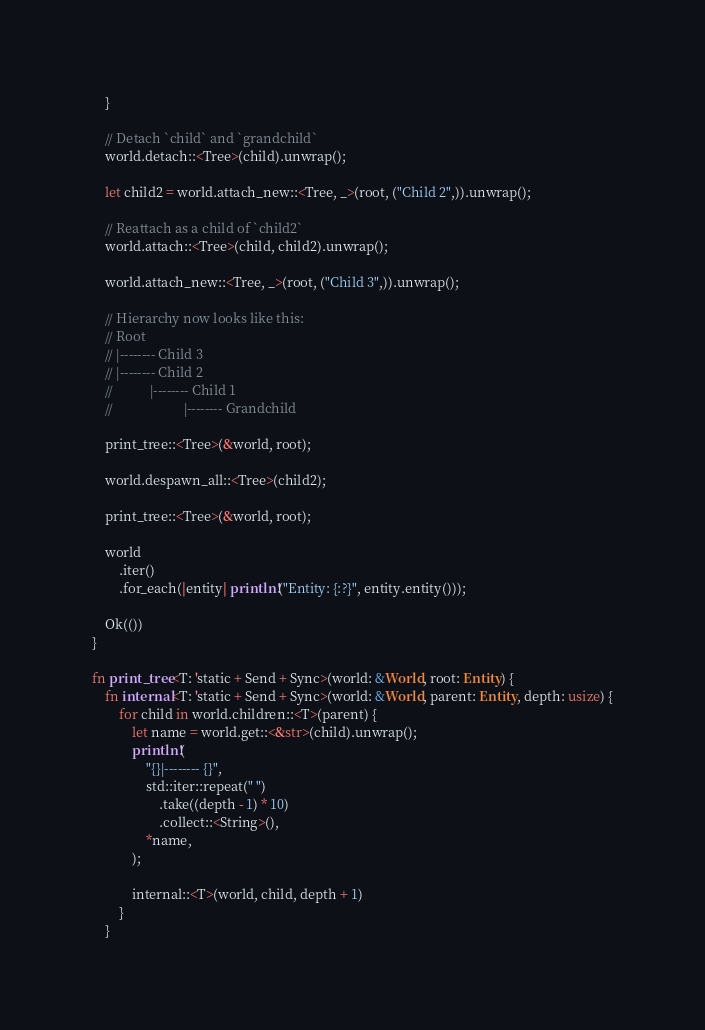Convert code to text. <code><loc_0><loc_0><loc_500><loc_500><_Rust_>    }

    // Detach `child` and `grandchild`
    world.detach::<Tree>(child).unwrap();

    let child2 = world.attach_new::<Tree, _>(root, ("Child 2",)).unwrap();

    // Reattach as a child of `child2`
    world.attach::<Tree>(child, child2).unwrap();

    world.attach_new::<Tree, _>(root, ("Child 3",)).unwrap();

    // Hierarchy now looks like this:
    // Root
    // |-------- Child 3
    // |-------- Child 2
    //           |-------- Child 1
    //                     |-------- Grandchild

    print_tree::<Tree>(&world, root);

    world.despawn_all::<Tree>(child2);

    print_tree::<Tree>(&world, root);

    world
        .iter()
        .for_each(|entity| println!("Entity: {:?}", entity.entity()));

    Ok(())
}

fn print_tree<T: 'static + Send + Sync>(world: &World, root: Entity) {
    fn internal<T: 'static + Send + Sync>(world: &World, parent: Entity, depth: usize) {
        for child in world.children::<T>(parent) {
            let name = world.get::<&str>(child).unwrap();
            println!(
                "{}|-------- {}",
                std::iter::repeat(" ")
                    .take((depth - 1) * 10)
                    .collect::<String>(),
                *name,
            );

            internal::<T>(world, child, depth + 1)
        }
    }
</code> 